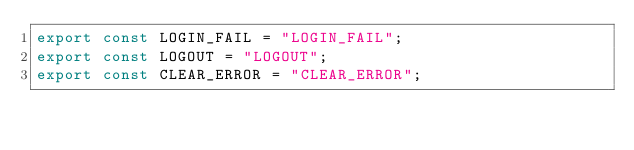<code> <loc_0><loc_0><loc_500><loc_500><_JavaScript_>export const LOGIN_FAIL = "LOGIN_FAIL";
export const LOGOUT = "LOGOUT";
export const CLEAR_ERROR = "CLEAR_ERROR";
</code> 